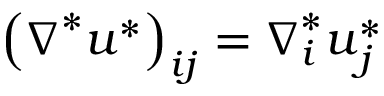Convert formula to latex. <formula><loc_0><loc_0><loc_500><loc_500>{ \left ( \nabla ^ { * } u ^ { * } \right ) } _ { i j } = \nabla _ { i } ^ { * } u _ { j } ^ { * }</formula> 